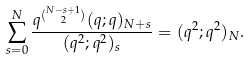Convert formula to latex. <formula><loc_0><loc_0><loc_500><loc_500>\sum _ { s = 0 } ^ { N } \frac { q ^ { \binom { N - s + 1 } { 2 } } ( q ; q ) _ { N + s } } { ( q ^ { 2 } ; q ^ { 2 } ) _ { s } } = ( q ^ { 2 } ; q ^ { 2 } ) _ { N } .</formula> 